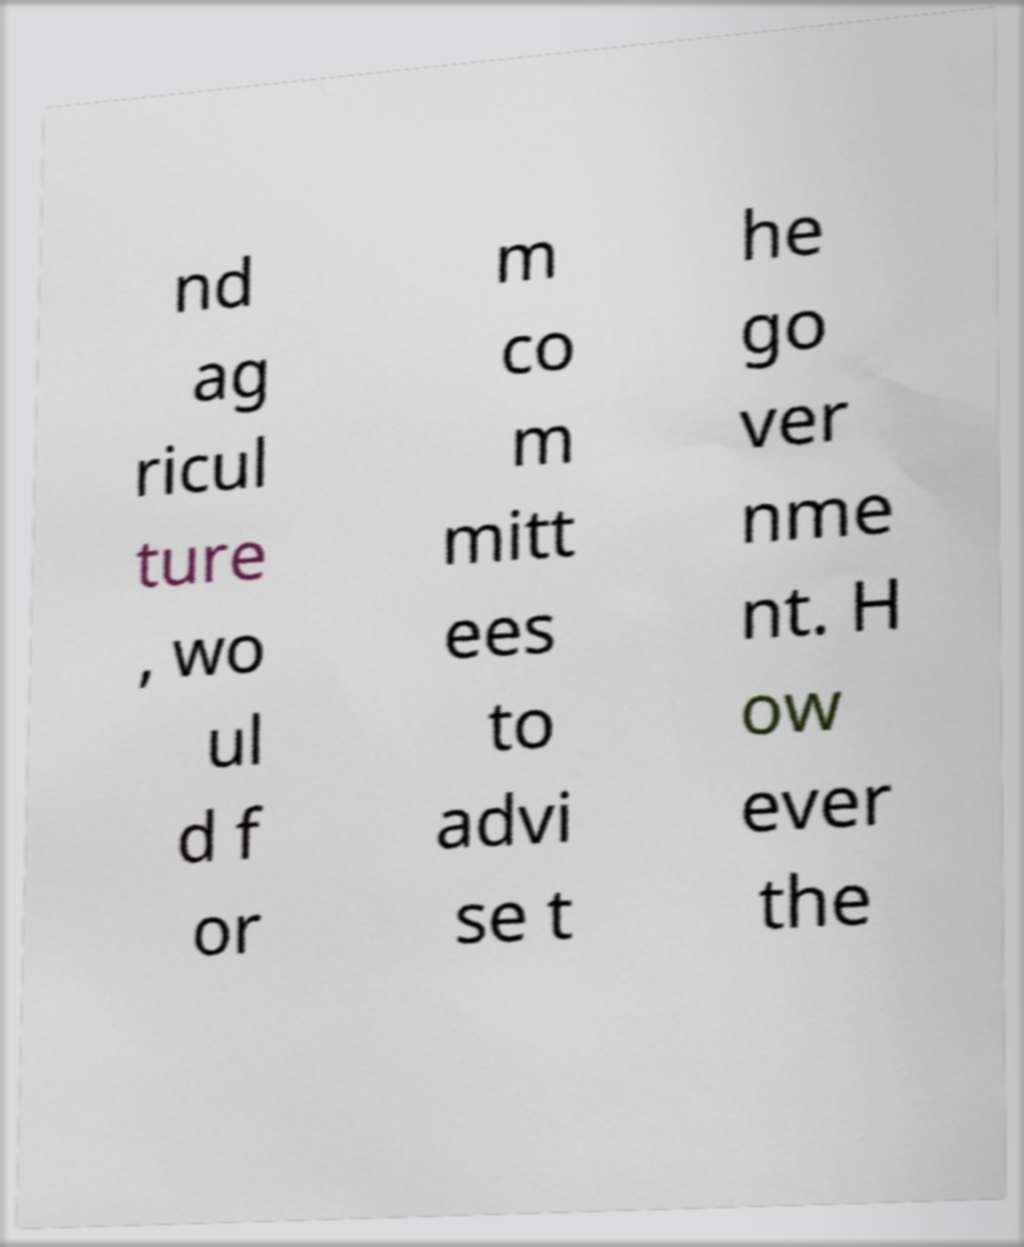Could you assist in decoding the text presented in this image and type it out clearly? nd ag ricul ture , wo ul d f or m co m mitt ees to advi se t he go ver nme nt. H ow ever the 